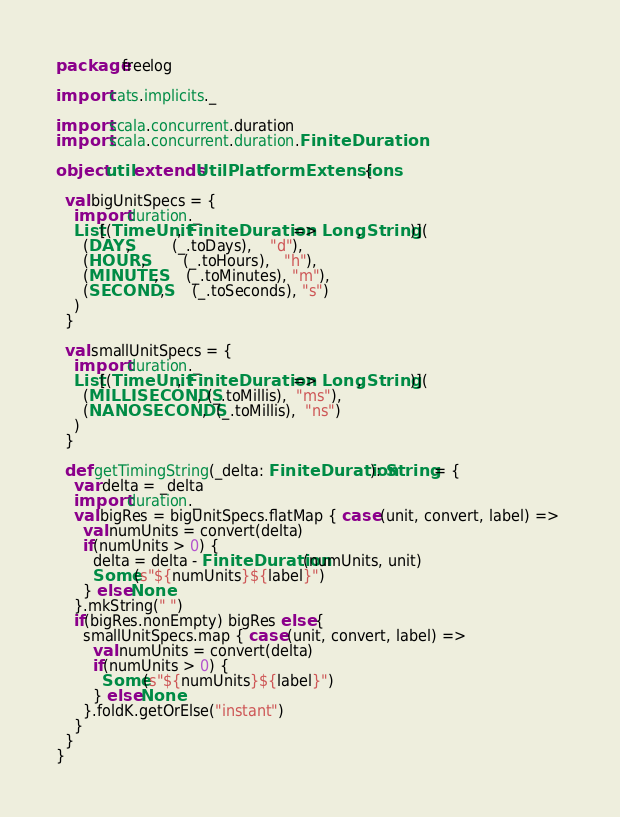<code> <loc_0><loc_0><loc_500><loc_500><_Scala_>package freelog

import cats.implicits._

import scala.concurrent.duration
import scala.concurrent.duration.FiniteDuration

object util extends UtilPlatformExtensions {

  val bigUnitSpecs = {
    import duration._
    List[(TimeUnit, FiniteDuration => Long, String)](
      (DAYS,         (_.toDays),    "d"),
      (HOURS,        (_.toHours),   "h"),
      (MINUTES,      (_.toMinutes), "m"),
      (SECONDS,      (_.toSeconds), "s")
    )
  }

  val smallUnitSpecs = {
    import duration._
    List[(TimeUnit, FiniteDuration => Long, String)](
      (MILLISECONDS, (_.toMillis),  "ms"),
      (NANOSECONDS,  (_.toMillis),  "ns")
    )
  }

  def getTimingString(_delta: FiniteDuration): String = {
    var delta = _delta
    import duration._
    val bigRes = bigUnitSpecs.flatMap { case (unit, convert, label) => 
      val numUnits = convert(delta)
      if(numUnits > 0) {
        delta = delta - FiniteDuration(numUnits, unit)
        Some(s"${numUnits}${label}")
      } else None
    }.mkString(" ")
    if(bigRes.nonEmpty) bigRes else {
      smallUnitSpecs.map { case (unit, convert, label) =>
        val numUnits = convert(delta)
        if(numUnits > 0) {
          Some(s"${numUnits}${label}")
        } else None
      }.foldK.getOrElse("instant")
    }
  }
}
</code> 